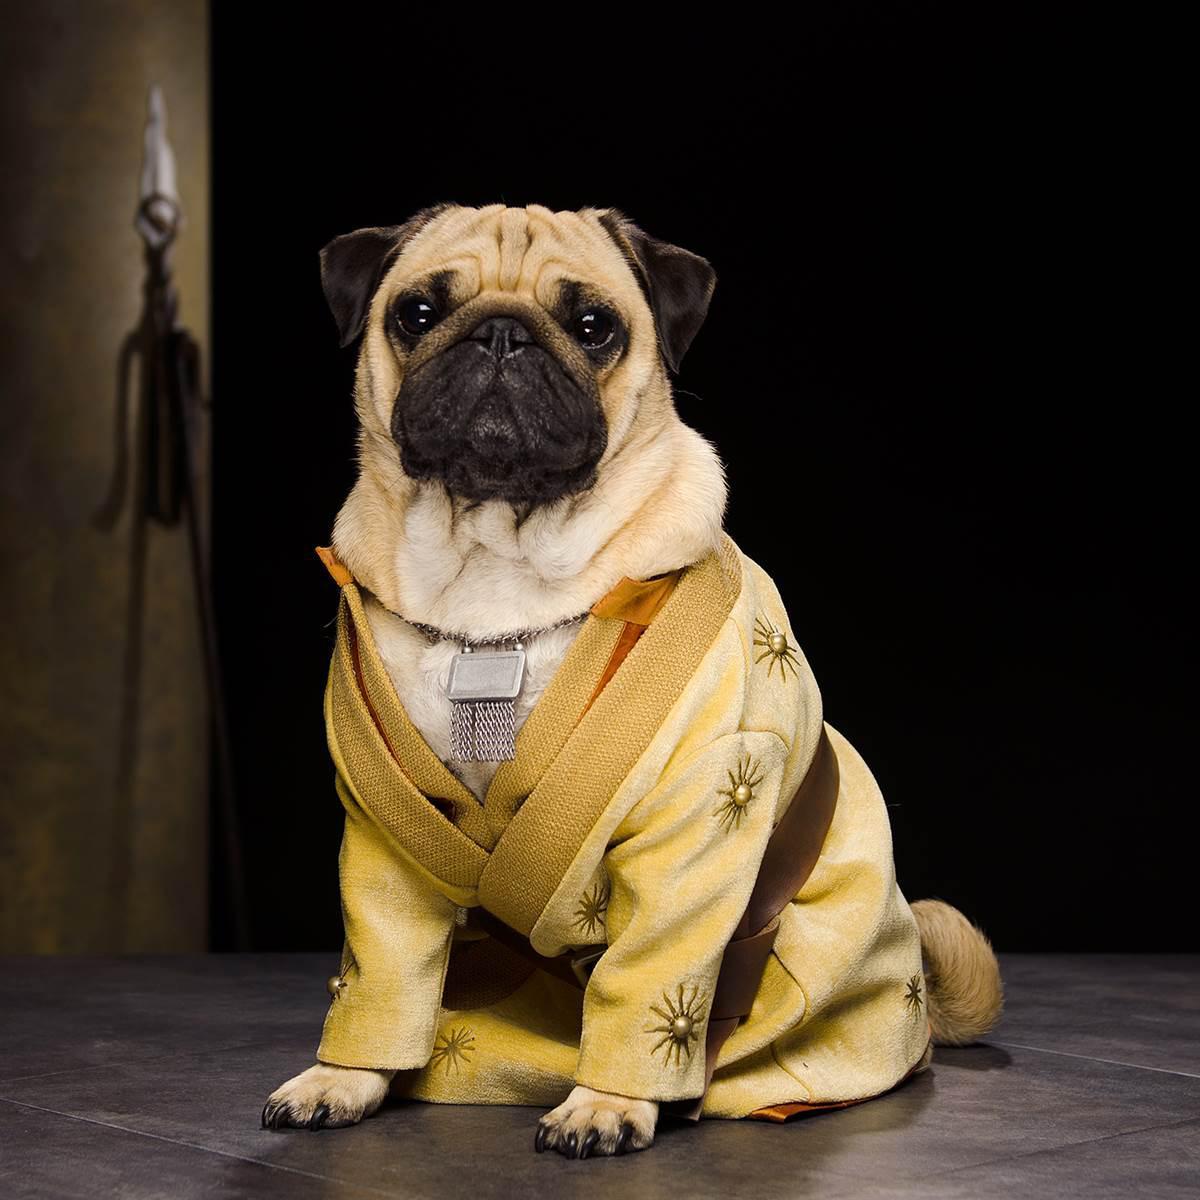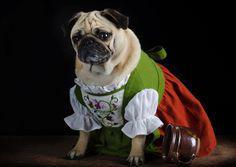The first image is the image on the left, the second image is the image on the right. For the images displayed, is the sentence "Three small dogs stand next to each other dressed in costume." factually correct? Answer yes or no. No. The first image is the image on the left, the second image is the image on the right. Examine the images to the left and right. Is the description "There are at least four dressed up pugs." accurate? Answer yes or no. No. 